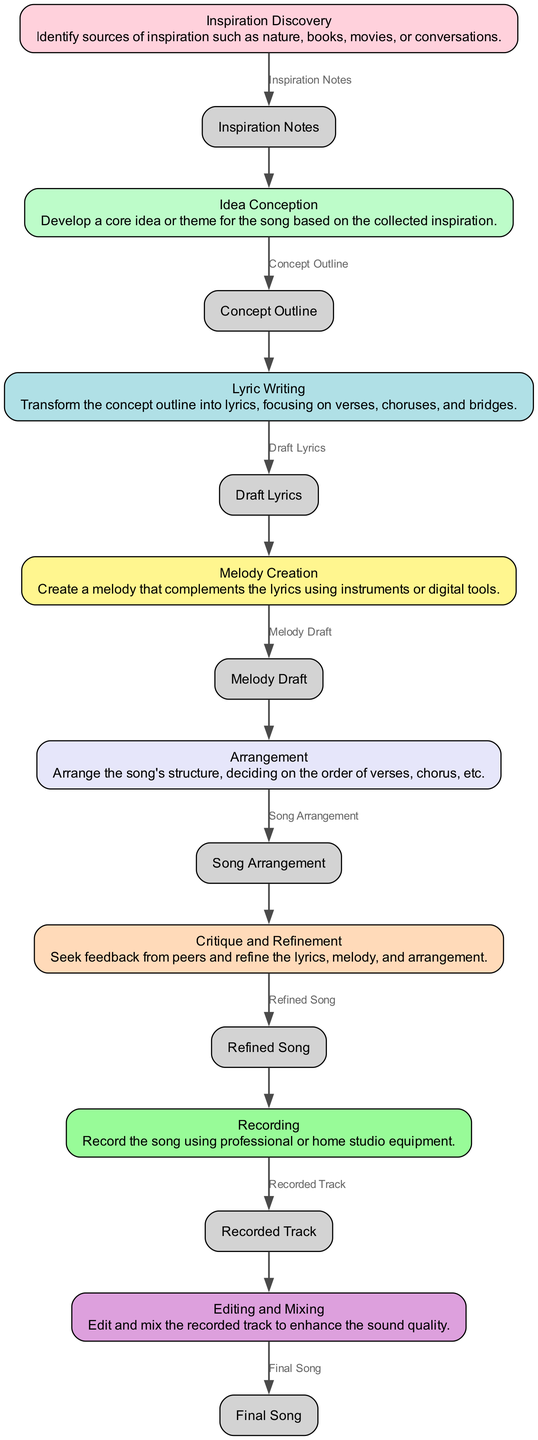What is the first step in the songwriting process? The diagram starts with "Inspiration Discovery" as the initial step. This is where sources of inspiration are identified.
Answer: Inspiration Discovery How many total steps are in the songwriting process? There are eight elements listed in the diagram representing different steps in the creative process workflow for songwriting.
Answer: Eight What is the output of the "Lyric Writing" step? The output from "Lyric Writing" is "Draft Lyrics," as specified in the outputs of each step in the diagram.
Answer: Draft Lyrics Which step follows after "Idea Conception"? After "Idea Conception," the next step is "Lyric Writing," as shown by the flow of the diagram connecting these two elements sequentially.
Answer: Lyric Writing What feedback action occurs after "Arrangement"? After "Arrangement," the step is "Critique and Refinement," indicating that feedback is sought and refinements are made to the song.
Answer: Critique and Refinement How does "Melody Creation" connect to "Lyric Writing"? "Melody Creation" takes its input directly from "Draft Lyrics" produced in the "Lyric Writing" step, which shows the dependency between these two processes.
Answer: Draft Lyrics What is the final output of the songwriting process? The final output of the workflow is "Final Song," which is the ultimate result of the entire process outlined in the diagram.
Answer: Final Song Which step has two inputs and one output? The "Critique and Refinement" step has one input from "Song Arrangement" and outputs "Refined Song," but it does not have two inputs. Since the diagram shows one input for this step, there isn’t a step with two inputs and one output in the provided workflow.
Answer: None What stage occurs right before "Recording"? The stage that occurs right before "Recording" is "Refined Song," which indicates the step in which the final version is prepared for recording.
Answer: Refined Song 